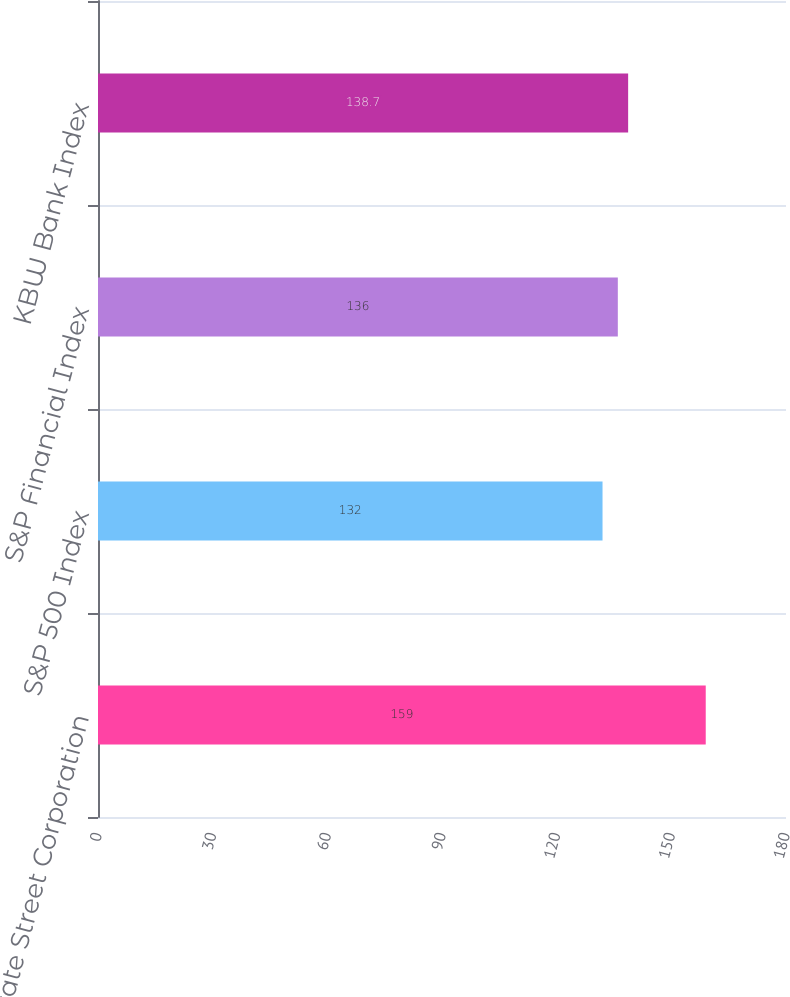<chart> <loc_0><loc_0><loc_500><loc_500><bar_chart><fcel>State Street Corporation<fcel>S&P 500 Index<fcel>S&P Financial Index<fcel>KBW Bank Index<nl><fcel>159<fcel>132<fcel>136<fcel>138.7<nl></chart> 